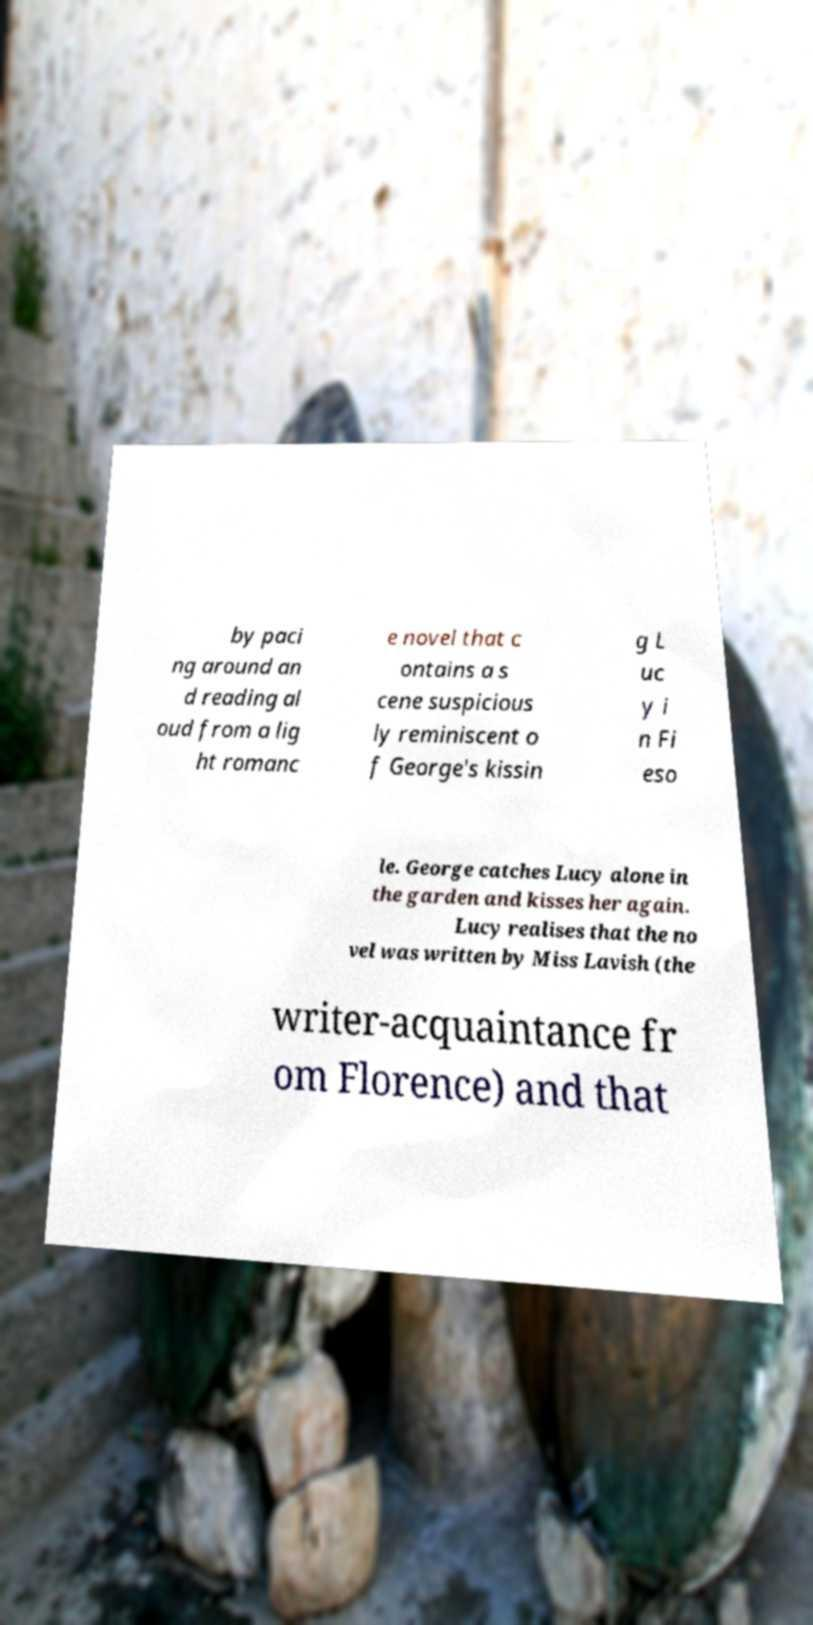Please identify and transcribe the text found in this image. by paci ng around an d reading al oud from a lig ht romanc e novel that c ontains a s cene suspicious ly reminiscent o f George's kissin g L uc y i n Fi eso le. George catches Lucy alone in the garden and kisses her again. Lucy realises that the no vel was written by Miss Lavish (the writer-acquaintance fr om Florence) and that 